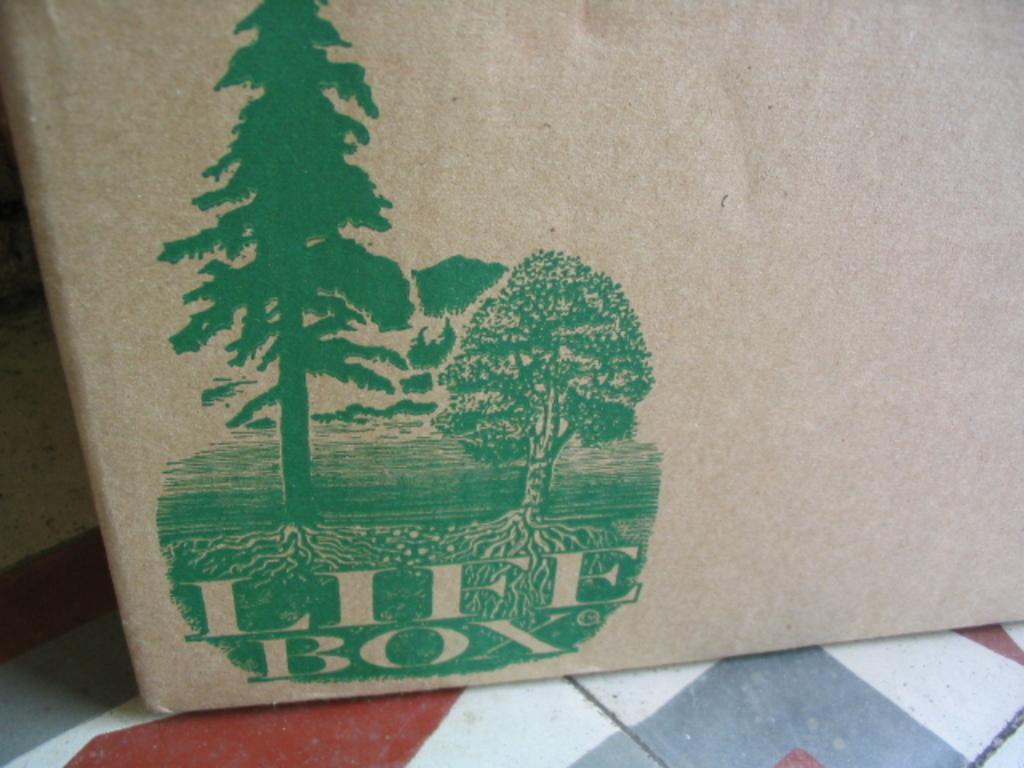<image>
Present a compact description of the photo's key features. A picture of trees has the words Life Box below. 